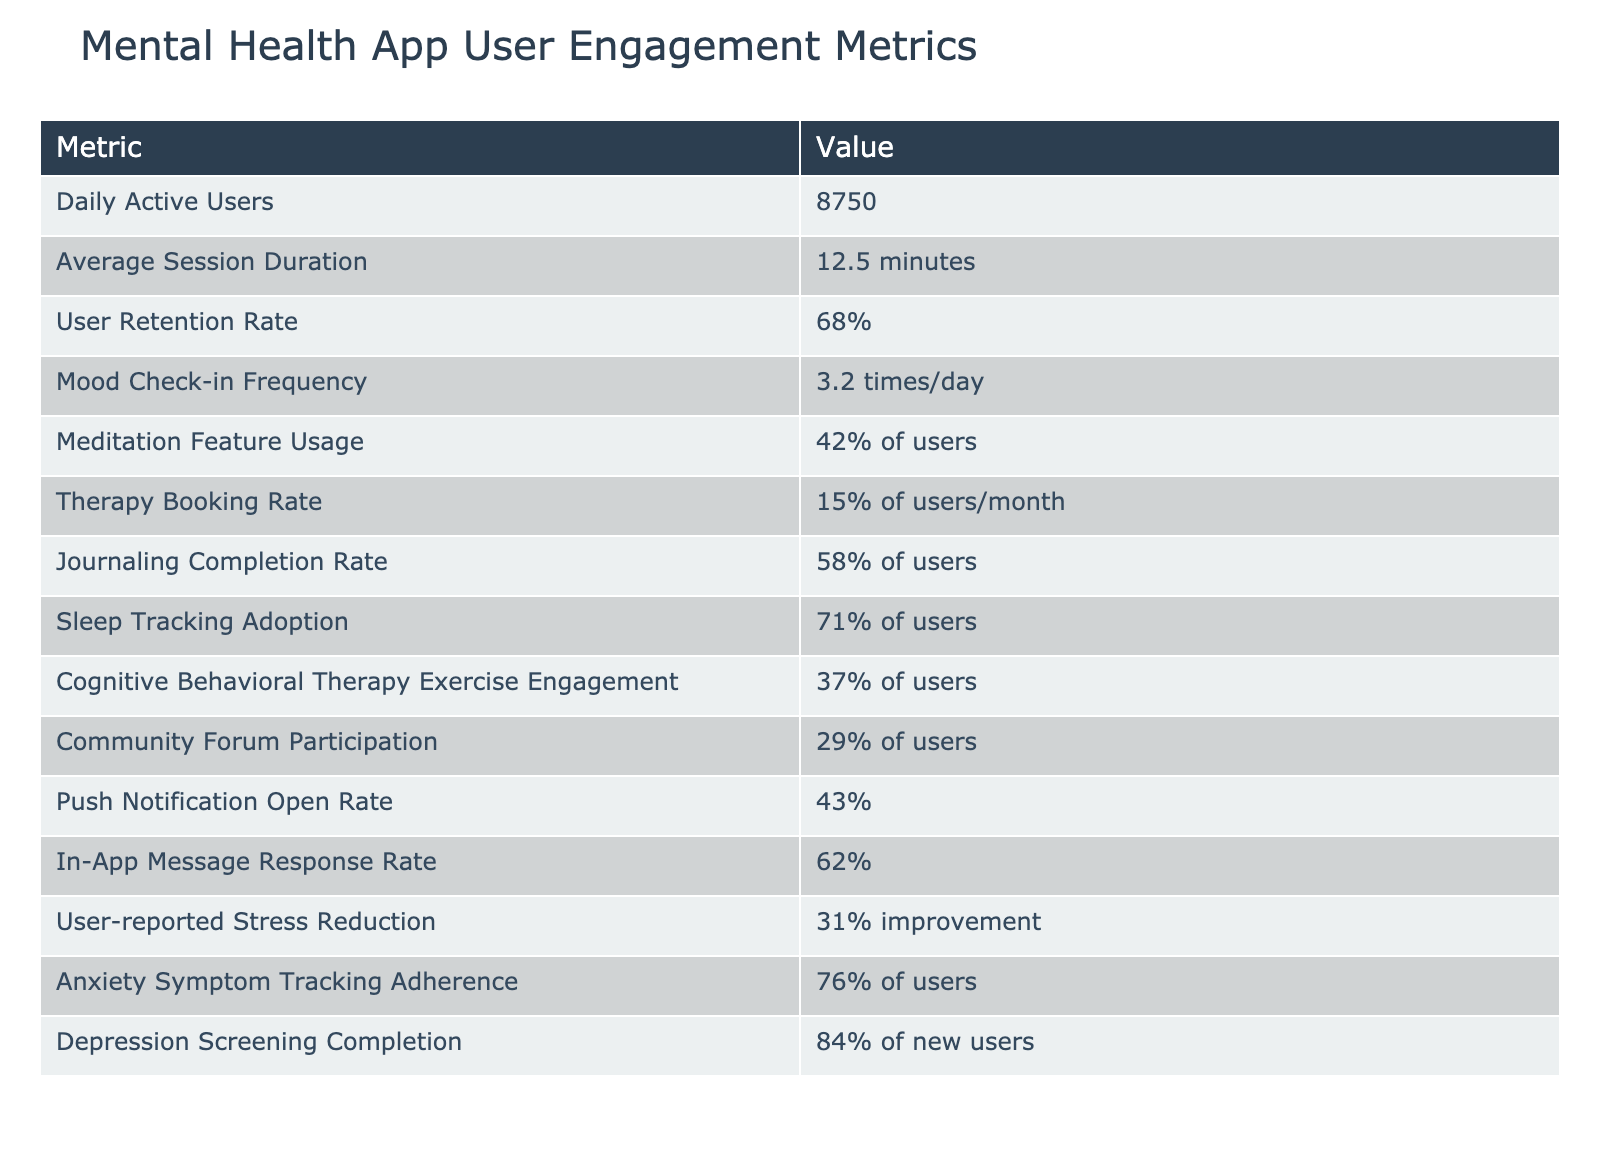What is the Daily Active User count? The table directly lists the number of Daily Active Users, which is 8750.
Answer: 8750 What percentage of users utilize the meditation feature? The table provides the meditation feature usage for users as 42%.
Answer: 42% Is the User Retention Rate above 70%? The User Retention Rate is given as 68%, which is below 70%, making the statement false.
Answer: No What is the average frequency of mood check-ins? According to the table, the average frequency of mood check-ins is listed as 3.2 times per day.
Answer: 3.2 times/day Calculate the percentage of users who do not engage with the Cognitive Behavioral Therapy exercises. The engagement rate for Cognitive Behavioral Therapy exercises is 37%, so the percentage of users not engaging in it is calculated as 100% - 37% = 63%.
Answer: 63% What is the combined percentage of users who actively use both the meditation feature and engage in journaling? The meditation feature usage is 42%, and the journaling completion rate is 58%. To find the combined user percentage, they are not directly additive, but we can infer a significant overlap. However, if they are taken separately, it’s the sum: 42% + 58% = 100%. This does not reflect actual combined users but gives an indicative metric for both.
Answer: 100% What is the difference between the Sleep Tracking Adoption and the Therapy Booking Rate? The Sleep Tracking Adoption is at 71%, while the Therapy Booking Rate is at 15%. The difference can be calculated as 71% - 15% = 56%.
Answer: 56% Are more users reporting stress reduction than those completing depression screenings? The User-reported Stress Reduction is noted at 31% improvement, whereas the Depression Screening Completion rate shows an 84% completion rate. Since 84% is greater than 31%, this statement is incorrect.
Answer: No How many features have user engagement metrics above 50%? From the table, we can note the following features: Journaling Completion Rate (58%), Sleep Tracking Adoption (71%), and Meditation Feature Usage (42%). Here, we have 3 features above 50%.
Answer: 3 